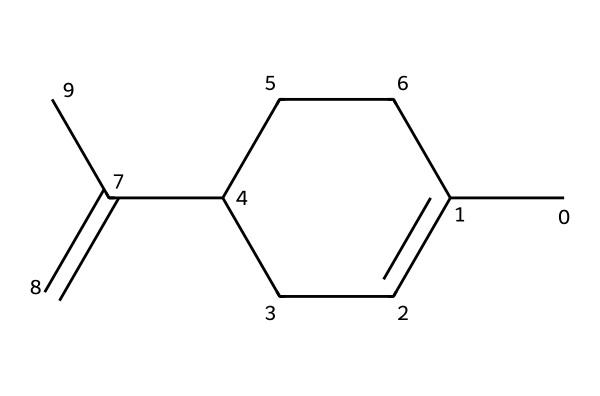What is the molecular formula of limonene? The molecular formula can be derived from the structure by counting the number of carbon (C) and hydrogen (H) atoms. There are 10 carbon atoms and 16 hydrogen atoms present in the structure. This gives the molecular formula of C10H16.
Answer: C10H16 How many rings are in the limonene structure? By examining the structure, it can be seen that there is one ring present, which is formed by the atoms connected in a cyclic manner.
Answer: 1 What type of hydrocarbon is limonene classified as? Limonene is classified as a monoterpene due to its structure, which consists of two isoprene units (10 carbon atoms). Monoterpenes are a subclass of terpenes.
Answer: monoterpene What functional groups are present in limonene? The structure of limonene indicates the presence of a double bond (alkene) between two carbon atoms. There are no other functional groups such as alcohols or ketones present.
Answer: alkene Is limonene saturated or unsaturated? Limonene contains a double bond, indicating that it is not fully saturated with hydrogen atoms, which qualifies it as an unsaturated hydrocarbon.
Answer: unsaturated What is the total number of hydrogen atoms connected to the carbon rings in limonene? In the cyclohexane-like ring of limonene, each carbon is typically bonded to two hydrogen atoms, but one carbon in the ring has a double bond. By analyzing the structure, the total number of hydrogen atoms connected to the carbon atoms in the ring is determined to be 10, while considering the structure overall.
Answer: 10 